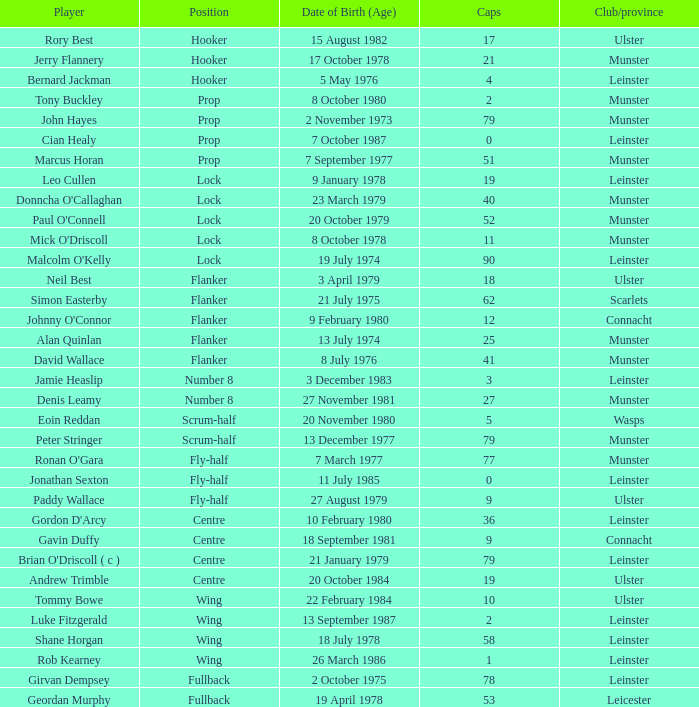For a player born on 13th december 1977, what is the sum of their caps? 79.0. 